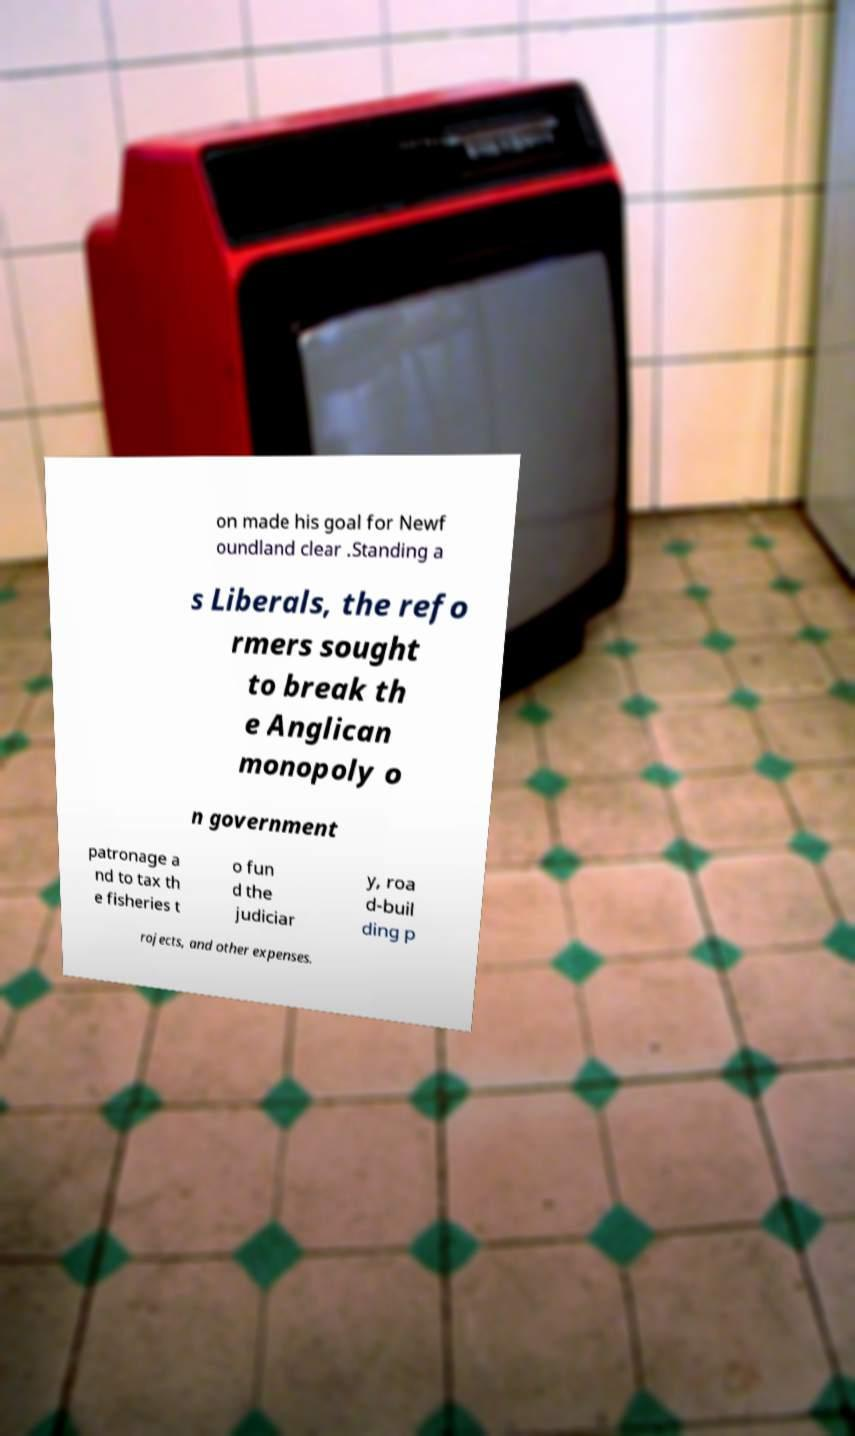There's text embedded in this image that I need extracted. Can you transcribe it verbatim? on made his goal for Newf oundland clear .Standing a s Liberals, the refo rmers sought to break th e Anglican monopoly o n government patronage a nd to tax th e fisheries t o fun d the judiciar y, roa d-buil ding p rojects, and other expenses. 